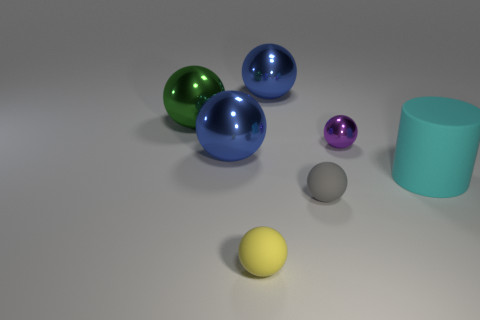What is the size of the blue metal ball that is in front of the big green shiny ball?
Provide a succinct answer. Large. There is a blue shiny thing that is behind the blue sphere in front of the small purple metallic sphere; how many tiny objects are to the right of it?
Give a very brief answer. 2. Are there any gray balls in front of the large cylinder?
Ensure brevity in your answer.  Yes. How many other things are there of the same size as the cyan cylinder?
Give a very brief answer. 3. There is a large object that is both to the right of the yellow matte sphere and behind the big cyan thing; what material is it made of?
Your answer should be very brief. Metal. Does the big matte object in front of the large green shiny ball have the same shape as the shiny thing to the right of the small gray matte thing?
Provide a succinct answer. No. The blue object in front of the small object on the right side of the tiny gray ball that is to the left of the small purple ball is what shape?
Your answer should be compact. Sphere. How many other objects are the same shape as the purple metallic object?
Keep it short and to the point. 5. What is the color of the other matte sphere that is the same size as the yellow ball?
Your answer should be very brief. Gray. How many spheres are either large red things or green things?
Keep it short and to the point. 1. 